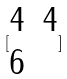Convert formula to latex. <formula><loc_0><loc_0><loc_500><loc_500>[ \begin{matrix} 4 & 4 \\ 6 \end{matrix} ]</formula> 